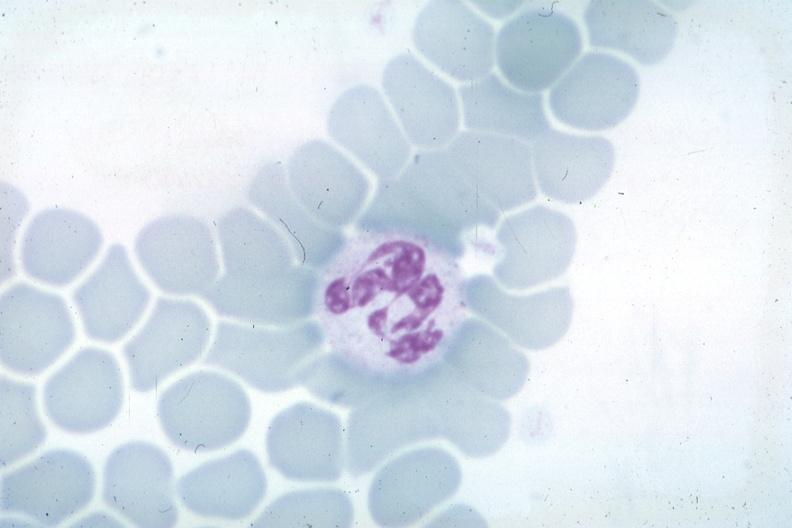does hematologic show wrights not the best photograph for color?
Answer the question using a single word or phrase. No 